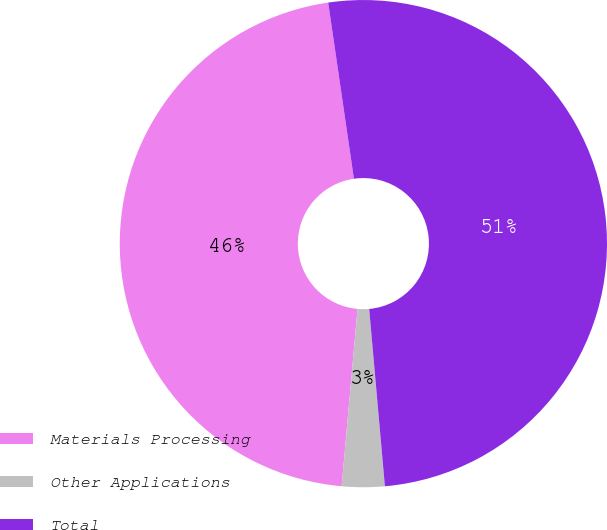<chart> <loc_0><loc_0><loc_500><loc_500><pie_chart><fcel>Materials Processing<fcel>Other Applications<fcel>Total<nl><fcel>46.27%<fcel>2.83%<fcel>50.9%<nl></chart> 